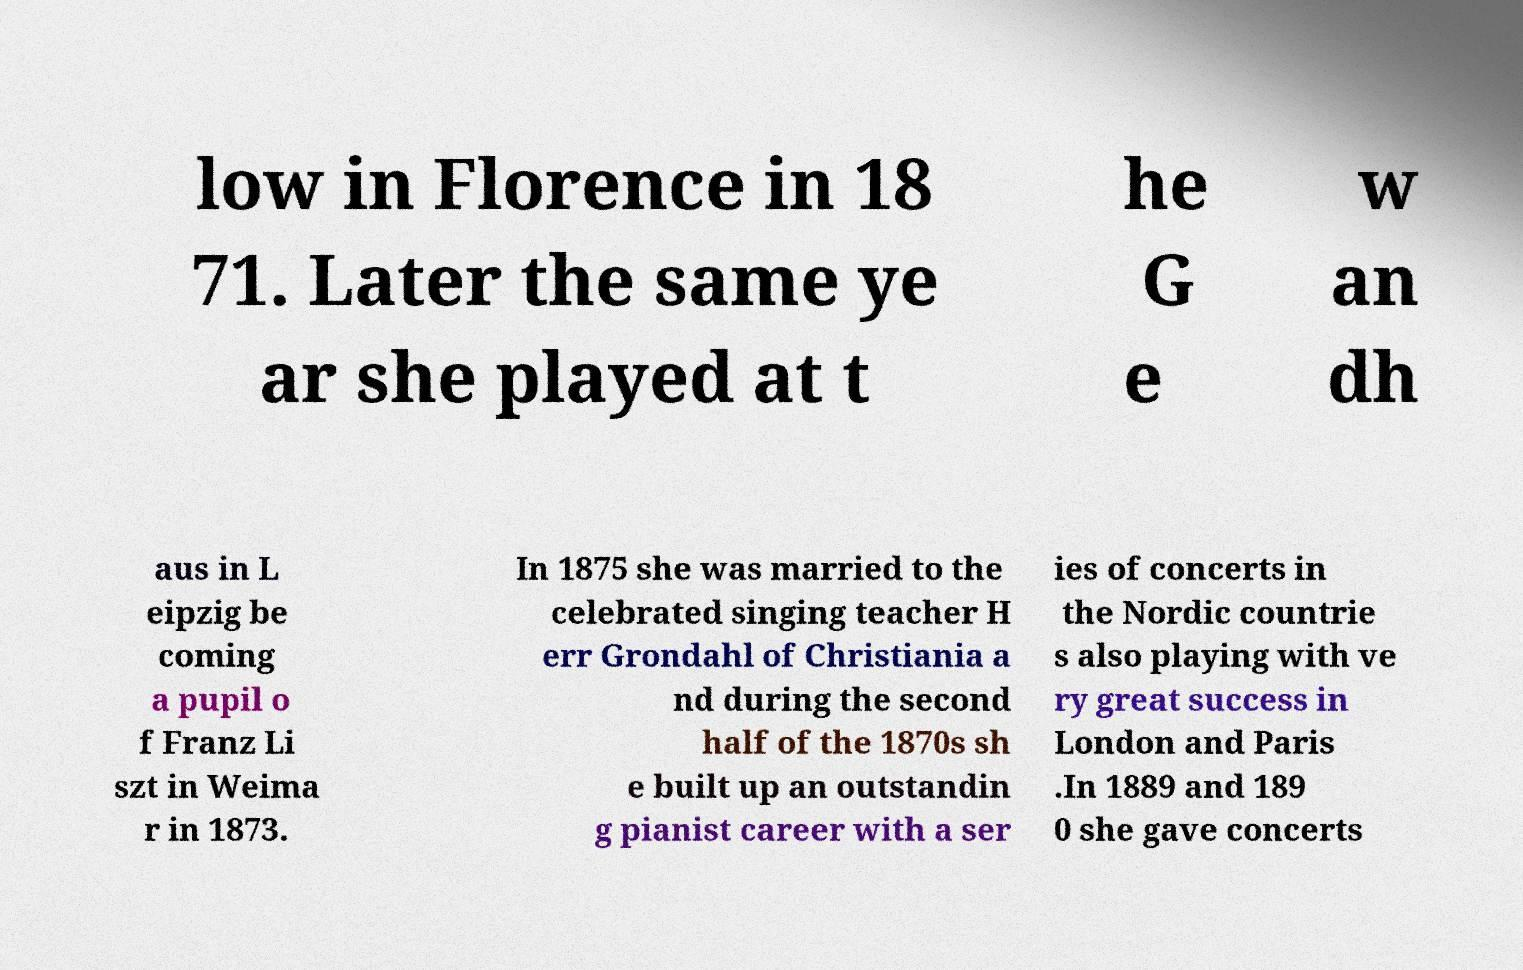For documentation purposes, I need the text within this image transcribed. Could you provide that? low in Florence in 18 71. Later the same ye ar she played at t he G e w an dh aus in L eipzig be coming a pupil o f Franz Li szt in Weima r in 1873. In 1875 she was married to the celebrated singing teacher H err Grondahl of Christiania a nd during the second half of the 1870s sh e built up an outstandin g pianist career with a ser ies of concerts in the Nordic countrie s also playing with ve ry great success in London and Paris .In 1889 and 189 0 she gave concerts 